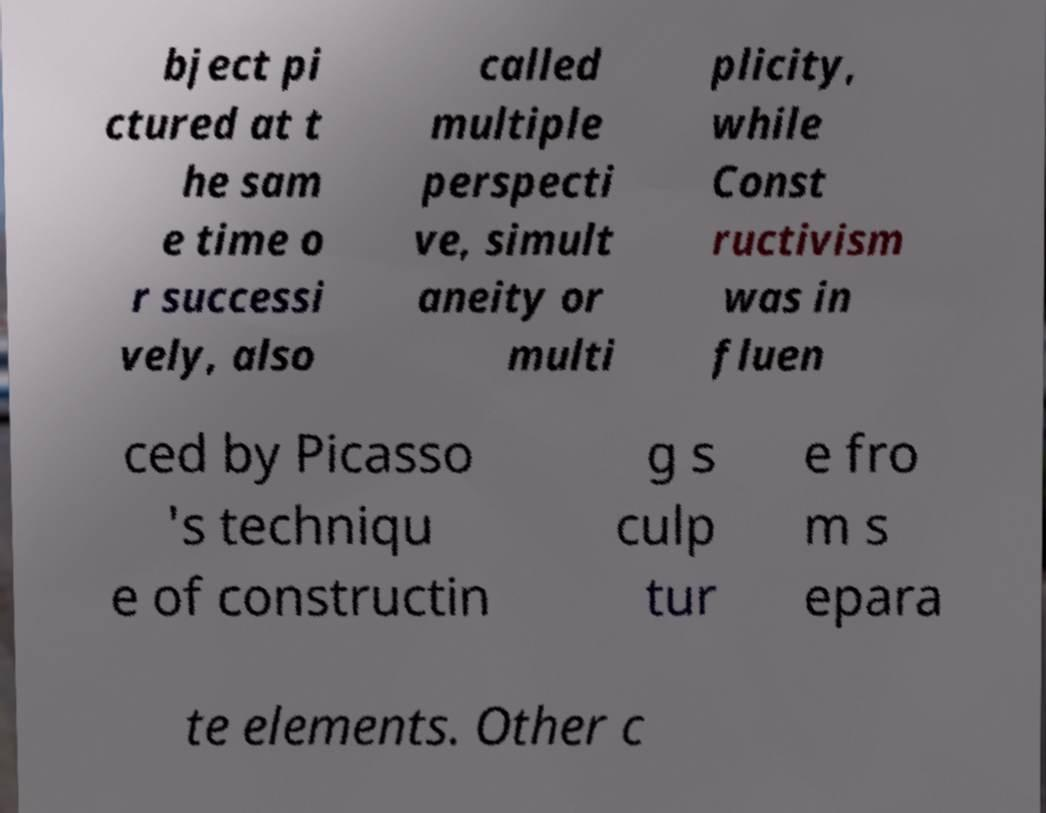Could you assist in decoding the text presented in this image and type it out clearly? bject pi ctured at t he sam e time o r successi vely, also called multiple perspecti ve, simult aneity or multi plicity, while Const ructivism was in fluen ced by Picasso 's techniqu e of constructin g s culp tur e fro m s epara te elements. Other c 